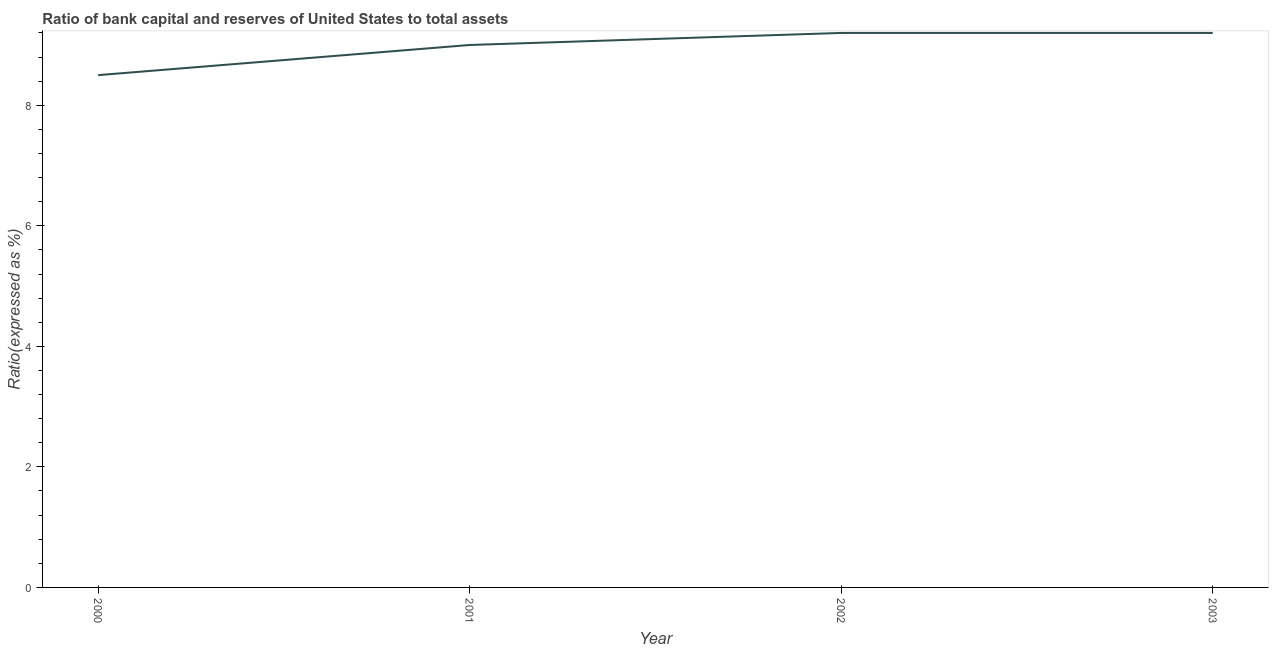What is the bank capital to assets ratio in 2001?
Keep it short and to the point. 9. Across all years, what is the minimum bank capital to assets ratio?
Your response must be concise. 8.5. What is the sum of the bank capital to assets ratio?
Provide a succinct answer. 35.9. What is the difference between the bank capital to assets ratio in 2001 and 2003?
Keep it short and to the point. -0.2. What is the average bank capital to assets ratio per year?
Provide a succinct answer. 8.97. Do a majority of the years between 2001 and 2000 (inclusive) have bank capital to assets ratio greater than 6.8 %?
Your response must be concise. No. Is the difference between the bank capital to assets ratio in 2000 and 2001 greater than the difference between any two years?
Make the answer very short. No. What is the difference between the highest and the second highest bank capital to assets ratio?
Offer a very short reply. 0. Is the sum of the bank capital to assets ratio in 2000 and 2003 greater than the maximum bank capital to assets ratio across all years?
Offer a terse response. Yes. What is the difference between the highest and the lowest bank capital to assets ratio?
Provide a short and direct response. 0.7. In how many years, is the bank capital to assets ratio greater than the average bank capital to assets ratio taken over all years?
Make the answer very short. 3. How many lines are there?
Your response must be concise. 1. How many years are there in the graph?
Your response must be concise. 4. Are the values on the major ticks of Y-axis written in scientific E-notation?
Your response must be concise. No. Does the graph contain grids?
Ensure brevity in your answer.  No. What is the title of the graph?
Your answer should be compact. Ratio of bank capital and reserves of United States to total assets. What is the label or title of the X-axis?
Provide a short and direct response. Year. What is the label or title of the Y-axis?
Your answer should be compact. Ratio(expressed as %). What is the Ratio(expressed as %) in 2000?
Offer a terse response. 8.5. What is the Ratio(expressed as %) in 2001?
Make the answer very short. 9. What is the Ratio(expressed as %) of 2003?
Give a very brief answer. 9.2. What is the difference between the Ratio(expressed as %) in 2000 and 2003?
Your answer should be compact. -0.7. What is the difference between the Ratio(expressed as %) in 2001 and 2002?
Offer a very short reply. -0.2. What is the ratio of the Ratio(expressed as %) in 2000 to that in 2001?
Provide a short and direct response. 0.94. What is the ratio of the Ratio(expressed as %) in 2000 to that in 2002?
Keep it short and to the point. 0.92. What is the ratio of the Ratio(expressed as %) in 2000 to that in 2003?
Make the answer very short. 0.92. What is the ratio of the Ratio(expressed as %) in 2001 to that in 2002?
Ensure brevity in your answer.  0.98. What is the ratio of the Ratio(expressed as %) in 2001 to that in 2003?
Offer a very short reply. 0.98. What is the ratio of the Ratio(expressed as %) in 2002 to that in 2003?
Offer a very short reply. 1. 